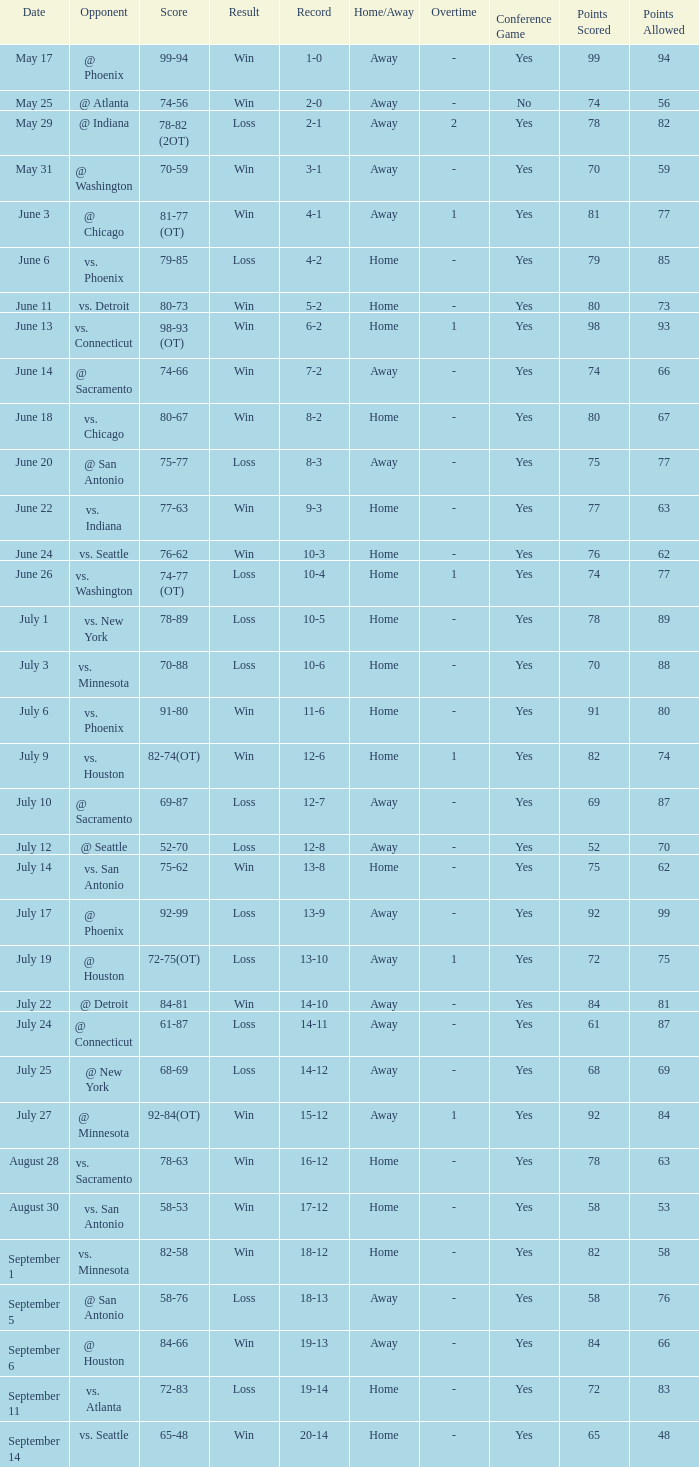What is the Opponent of the game with a Score of 74-66? @ Sacramento. 